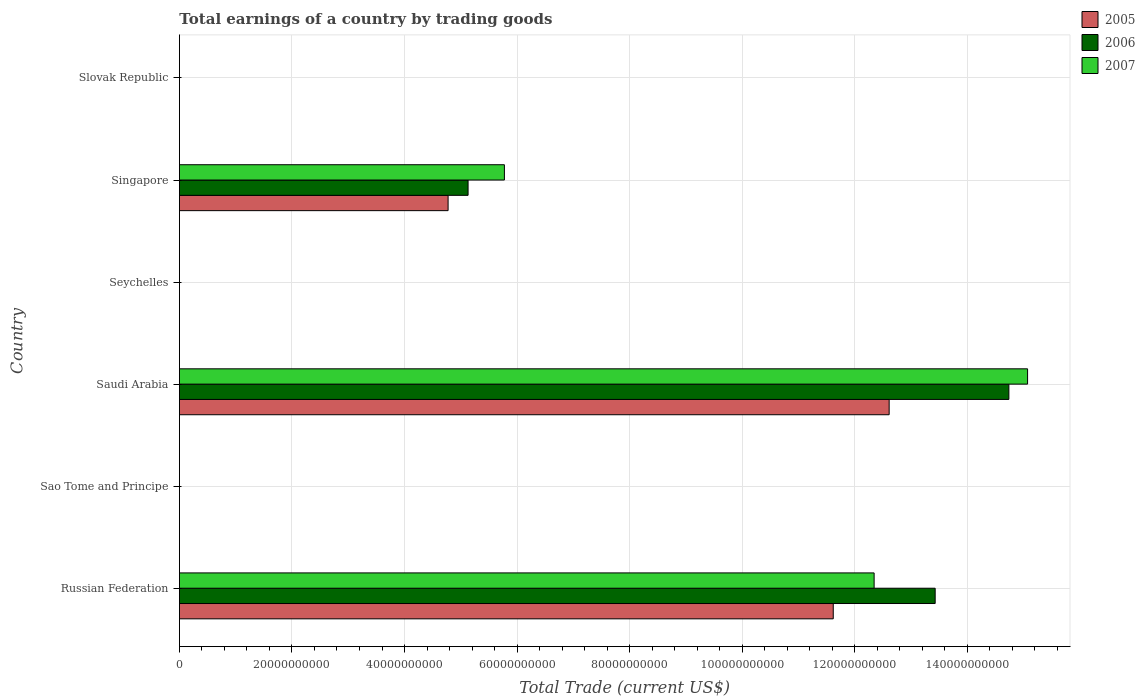How many bars are there on the 3rd tick from the top?
Your response must be concise. 0. How many bars are there on the 4th tick from the bottom?
Keep it short and to the point. 0. What is the label of the 4th group of bars from the top?
Ensure brevity in your answer.  Saudi Arabia. Across all countries, what is the maximum total earnings in 2007?
Give a very brief answer. 1.51e+11. Across all countries, what is the minimum total earnings in 2006?
Make the answer very short. 0. In which country was the total earnings in 2007 maximum?
Your answer should be very brief. Saudi Arabia. What is the total total earnings in 2006 in the graph?
Provide a succinct answer. 3.33e+11. What is the difference between the total earnings in 2005 in Russian Federation and that in Saudi Arabia?
Give a very brief answer. -9.93e+09. What is the difference between the total earnings in 2007 in Saudi Arabia and the total earnings in 2005 in Russian Federation?
Give a very brief answer. 3.45e+1. What is the average total earnings in 2005 per country?
Your answer should be very brief. 4.83e+1. What is the difference between the total earnings in 2006 and total earnings in 2007 in Russian Federation?
Offer a terse response. 1.08e+1. Is the total earnings in 2007 in Russian Federation less than that in Saudi Arabia?
Your response must be concise. Yes. What is the difference between the highest and the second highest total earnings in 2005?
Ensure brevity in your answer.  9.93e+09. What is the difference between the highest and the lowest total earnings in 2005?
Give a very brief answer. 1.26e+11. In how many countries, is the total earnings in 2006 greater than the average total earnings in 2006 taken over all countries?
Give a very brief answer. 2. Is it the case that in every country, the sum of the total earnings in 2007 and total earnings in 2005 is greater than the total earnings in 2006?
Provide a succinct answer. No. How many bars are there?
Your response must be concise. 9. How many countries are there in the graph?
Your response must be concise. 6. What is the difference between two consecutive major ticks on the X-axis?
Your answer should be very brief. 2.00e+1. Are the values on the major ticks of X-axis written in scientific E-notation?
Your answer should be compact. No. Where does the legend appear in the graph?
Give a very brief answer. Top right. What is the title of the graph?
Your answer should be very brief. Total earnings of a country by trading goods. Does "1974" appear as one of the legend labels in the graph?
Your answer should be very brief. No. What is the label or title of the X-axis?
Ensure brevity in your answer.  Total Trade (current US$). What is the label or title of the Y-axis?
Offer a very short reply. Country. What is the Total Trade (current US$) in 2005 in Russian Federation?
Make the answer very short. 1.16e+11. What is the Total Trade (current US$) of 2006 in Russian Federation?
Provide a short and direct response. 1.34e+11. What is the Total Trade (current US$) in 2007 in Russian Federation?
Ensure brevity in your answer.  1.23e+11. What is the Total Trade (current US$) of 2007 in Sao Tome and Principe?
Provide a succinct answer. 0. What is the Total Trade (current US$) in 2005 in Saudi Arabia?
Your answer should be compact. 1.26e+11. What is the Total Trade (current US$) of 2006 in Saudi Arabia?
Your response must be concise. 1.47e+11. What is the Total Trade (current US$) of 2007 in Saudi Arabia?
Offer a very short reply. 1.51e+11. What is the Total Trade (current US$) in 2006 in Seychelles?
Give a very brief answer. 0. What is the Total Trade (current US$) in 2007 in Seychelles?
Make the answer very short. 0. What is the Total Trade (current US$) of 2005 in Singapore?
Offer a very short reply. 4.77e+1. What is the Total Trade (current US$) of 2006 in Singapore?
Offer a very short reply. 5.13e+1. What is the Total Trade (current US$) of 2007 in Singapore?
Your answer should be very brief. 5.77e+1. What is the Total Trade (current US$) of 2006 in Slovak Republic?
Provide a succinct answer. 0. What is the Total Trade (current US$) in 2007 in Slovak Republic?
Offer a very short reply. 0. Across all countries, what is the maximum Total Trade (current US$) in 2005?
Ensure brevity in your answer.  1.26e+11. Across all countries, what is the maximum Total Trade (current US$) of 2006?
Provide a short and direct response. 1.47e+11. Across all countries, what is the maximum Total Trade (current US$) in 2007?
Keep it short and to the point. 1.51e+11. Across all countries, what is the minimum Total Trade (current US$) of 2006?
Your response must be concise. 0. Across all countries, what is the minimum Total Trade (current US$) of 2007?
Give a very brief answer. 0. What is the total Total Trade (current US$) of 2005 in the graph?
Provide a short and direct response. 2.90e+11. What is the total Total Trade (current US$) of 2006 in the graph?
Ensure brevity in your answer.  3.33e+11. What is the total Total Trade (current US$) in 2007 in the graph?
Give a very brief answer. 3.32e+11. What is the difference between the Total Trade (current US$) in 2005 in Russian Federation and that in Saudi Arabia?
Your answer should be compact. -9.93e+09. What is the difference between the Total Trade (current US$) of 2006 in Russian Federation and that in Saudi Arabia?
Offer a very short reply. -1.31e+1. What is the difference between the Total Trade (current US$) in 2007 in Russian Federation and that in Saudi Arabia?
Offer a terse response. -2.73e+1. What is the difference between the Total Trade (current US$) of 2005 in Russian Federation and that in Singapore?
Your answer should be very brief. 6.84e+1. What is the difference between the Total Trade (current US$) of 2006 in Russian Federation and that in Singapore?
Offer a terse response. 8.30e+1. What is the difference between the Total Trade (current US$) of 2007 in Russian Federation and that in Singapore?
Your answer should be compact. 6.57e+1. What is the difference between the Total Trade (current US$) of 2005 in Saudi Arabia and that in Singapore?
Offer a terse response. 7.84e+1. What is the difference between the Total Trade (current US$) in 2006 in Saudi Arabia and that in Singapore?
Offer a terse response. 9.61e+1. What is the difference between the Total Trade (current US$) in 2007 in Saudi Arabia and that in Singapore?
Provide a succinct answer. 9.30e+1. What is the difference between the Total Trade (current US$) in 2005 in Russian Federation and the Total Trade (current US$) in 2006 in Saudi Arabia?
Provide a short and direct response. -3.12e+1. What is the difference between the Total Trade (current US$) in 2005 in Russian Federation and the Total Trade (current US$) in 2007 in Saudi Arabia?
Offer a terse response. -3.45e+1. What is the difference between the Total Trade (current US$) in 2006 in Russian Federation and the Total Trade (current US$) in 2007 in Saudi Arabia?
Your answer should be very brief. -1.64e+1. What is the difference between the Total Trade (current US$) of 2005 in Russian Federation and the Total Trade (current US$) of 2006 in Singapore?
Give a very brief answer. 6.49e+1. What is the difference between the Total Trade (current US$) of 2005 in Russian Federation and the Total Trade (current US$) of 2007 in Singapore?
Provide a succinct answer. 5.84e+1. What is the difference between the Total Trade (current US$) in 2006 in Russian Federation and the Total Trade (current US$) in 2007 in Singapore?
Provide a short and direct response. 7.65e+1. What is the difference between the Total Trade (current US$) of 2005 in Saudi Arabia and the Total Trade (current US$) of 2006 in Singapore?
Offer a very short reply. 7.48e+1. What is the difference between the Total Trade (current US$) of 2005 in Saudi Arabia and the Total Trade (current US$) of 2007 in Singapore?
Your response must be concise. 6.84e+1. What is the difference between the Total Trade (current US$) in 2006 in Saudi Arabia and the Total Trade (current US$) in 2007 in Singapore?
Your answer should be compact. 8.96e+1. What is the average Total Trade (current US$) in 2005 per country?
Keep it short and to the point. 4.83e+1. What is the average Total Trade (current US$) in 2006 per country?
Your answer should be very brief. 5.55e+1. What is the average Total Trade (current US$) in 2007 per country?
Offer a terse response. 5.53e+1. What is the difference between the Total Trade (current US$) in 2005 and Total Trade (current US$) in 2006 in Russian Federation?
Your answer should be compact. -1.81e+1. What is the difference between the Total Trade (current US$) in 2005 and Total Trade (current US$) in 2007 in Russian Federation?
Give a very brief answer. -7.26e+09. What is the difference between the Total Trade (current US$) in 2006 and Total Trade (current US$) in 2007 in Russian Federation?
Give a very brief answer. 1.08e+1. What is the difference between the Total Trade (current US$) of 2005 and Total Trade (current US$) of 2006 in Saudi Arabia?
Ensure brevity in your answer.  -2.13e+1. What is the difference between the Total Trade (current US$) of 2005 and Total Trade (current US$) of 2007 in Saudi Arabia?
Your response must be concise. -2.46e+1. What is the difference between the Total Trade (current US$) in 2006 and Total Trade (current US$) in 2007 in Saudi Arabia?
Your answer should be very brief. -3.32e+09. What is the difference between the Total Trade (current US$) in 2005 and Total Trade (current US$) in 2006 in Singapore?
Provide a short and direct response. -3.55e+09. What is the difference between the Total Trade (current US$) of 2005 and Total Trade (current US$) of 2007 in Singapore?
Make the answer very short. -1.00e+1. What is the difference between the Total Trade (current US$) in 2006 and Total Trade (current US$) in 2007 in Singapore?
Offer a terse response. -6.46e+09. What is the ratio of the Total Trade (current US$) of 2005 in Russian Federation to that in Saudi Arabia?
Your answer should be very brief. 0.92. What is the ratio of the Total Trade (current US$) of 2006 in Russian Federation to that in Saudi Arabia?
Your response must be concise. 0.91. What is the ratio of the Total Trade (current US$) in 2007 in Russian Federation to that in Saudi Arabia?
Provide a succinct answer. 0.82. What is the ratio of the Total Trade (current US$) of 2005 in Russian Federation to that in Singapore?
Offer a terse response. 2.43. What is the ratio of the Total Trade (current US$) of 2006 in Russian Federation to that in Singapore?
Your answer should be very brief. 2.62. What is the ratio of the Total Trade (current US$) in 2007 in Russian Federation to that in Singapore?
Ensure brevity in your answer.  2.14. What is the ratio of the Total Trade (current US$) of 2005 in Saudi Arabia to that in Singapore?
Provide a succinct answer. 2.64. What is the ratio of the Total Trade (current US$) in 2006 in Saudi Arabia to that in Singapore?
Your response must be concise. 2.87. What is the ratio of the Total Trade (current US$) of 2007 in Saudi Arabia to that in Singapore?
Your answer should be compact. 2.61. What is the difference between the highest and the second highest Total Trade (current US$) of 2005?
Ensure brevity in your answer.  9.93e+09. What is the difference between the highest and the second highest Total Trade (current US$) in 2006?
Provide a short and direct response. 1.31e+1. What is the difference between the highest and the second highest Total Trade (current US$) of 2007?
Ensure brevity in your answer.  2.73e+1. What is the difference between the highest and the lowest Total Trade (current US$) of 2005?
Your response must be concise. 1.26e+11. What is the difference between the highest and the lowest Total Trade (current US$) of 2006?
Provide a short and direct response. 1.47e+11. What is the difference between the highest and the lowest Total Trade (current US$) in 2007?
Keep it short and to the point. 1.51e+11. 